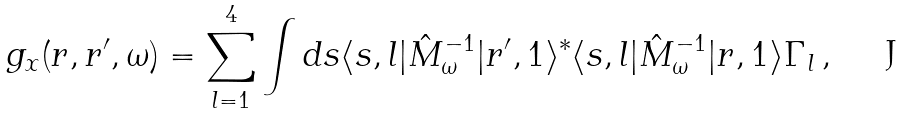<formula> <loc_0><loc_0><loc_500><loc_500>g _ { x } ( { r } , { r ^ { \prime } } , \omega ) = \sum _ { l = 1 } ^ { 4 } \int d { s } \langle { s } , l | \hat { M } _ { \omega } ^ { - 1 } | { r ^ { \prime } } , 1 \rangle ^ { * } \langle { s } , l | \hat { M } _ { \omega } ^ { - 1 } | { r } , 1 \rangle \Gamma _ { l } \, ,</formula> 